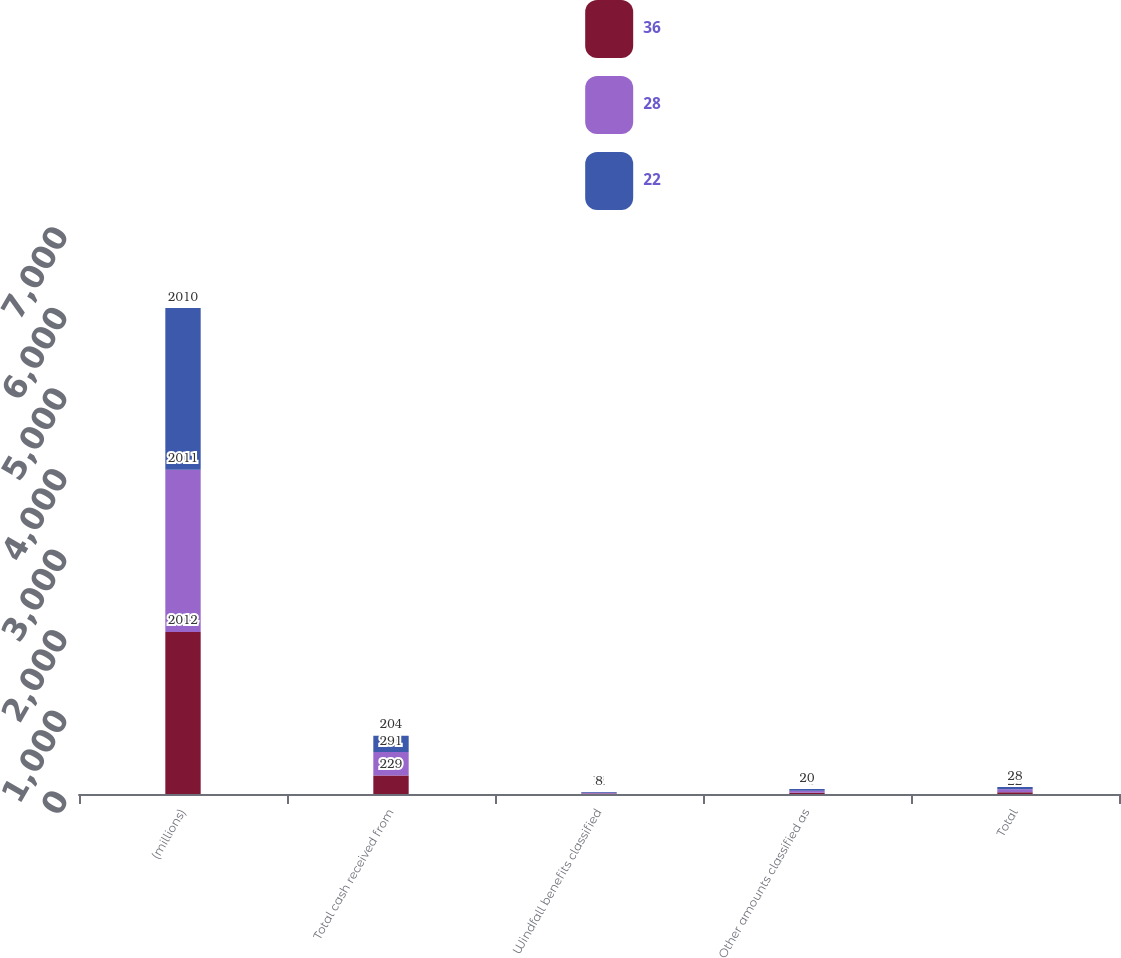Convert chart. <chart><loc_0><loc_0><loc_500><loc_500><stacked_bar_chart><ecel><fcel>(millions)<fcel>Total cash received from<fcel>Windfall benefits classified<fcel>Other amounts classified as<fcel>Total<nl><fcel>36<fcel>2012<fcel>229<fcel>6<fcel>16<fcel>22<nl><fcel>28<fcel>2011<fcel>291<fcel>11<fcel>25<fcel>36<nl><fcel>22<fcel>2010<fcel>204<fcel>8<fcel>20<fcel>28<nl></chart> 